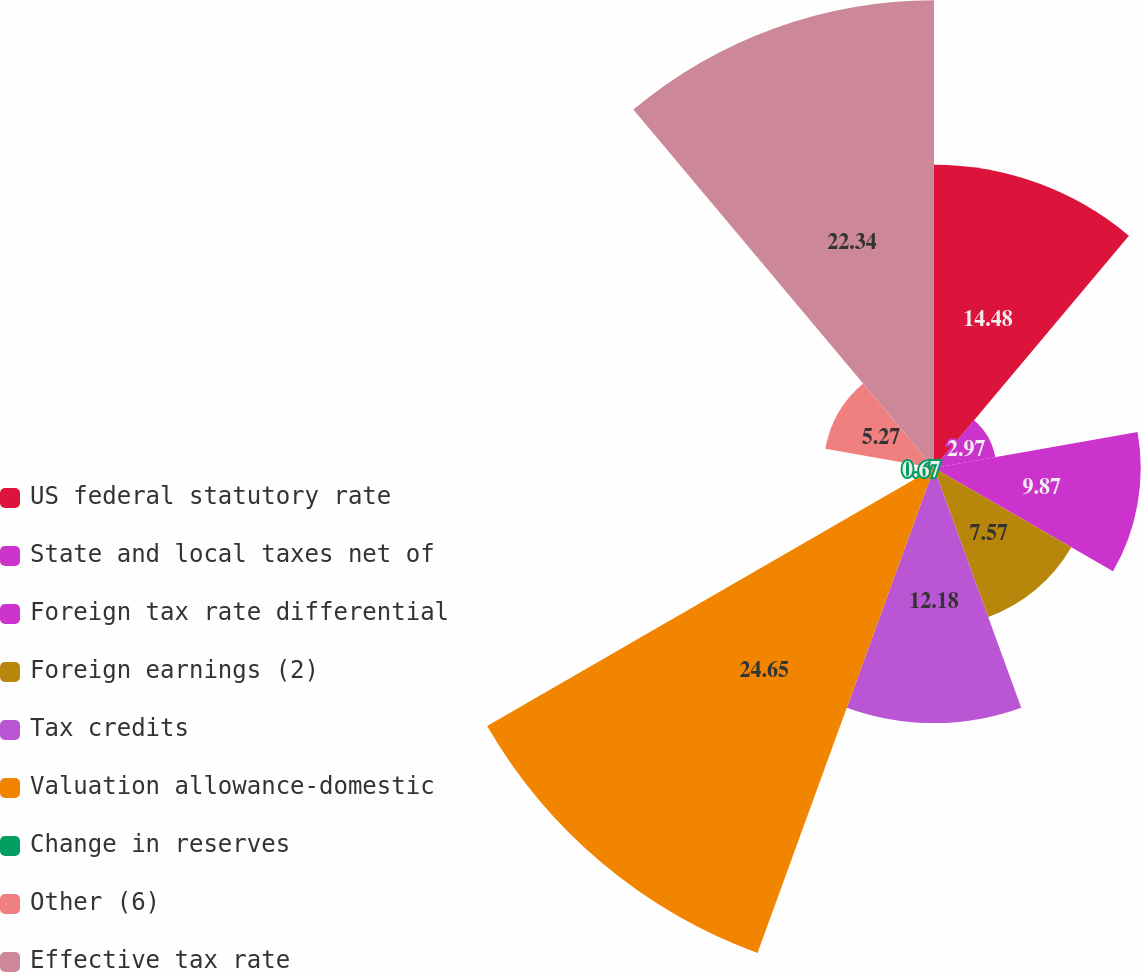Convert chart to OTSL. <chart><loc_0><loc_0><loc_500><loc_500><pie_chart><fcel>US federal statutory rate<fcel>State and local taxes net of<fcel>Foreign tax rate differential<fcel>Foreign earnings (2)<fcel>Tax credits<fcel>Valuation allowance-domestic<fcel>Change in reserves<fcel>Other (6)<fcel>Effective tax rate<nl><fcel>14.48%<fcel>2.97%<fcel>9.87%<fcel>7.57%<fcel>12.18%<fcel>24.64%<fcel>0.67%<fcel>5.27%<fcel>22.34%<nl></chart> 